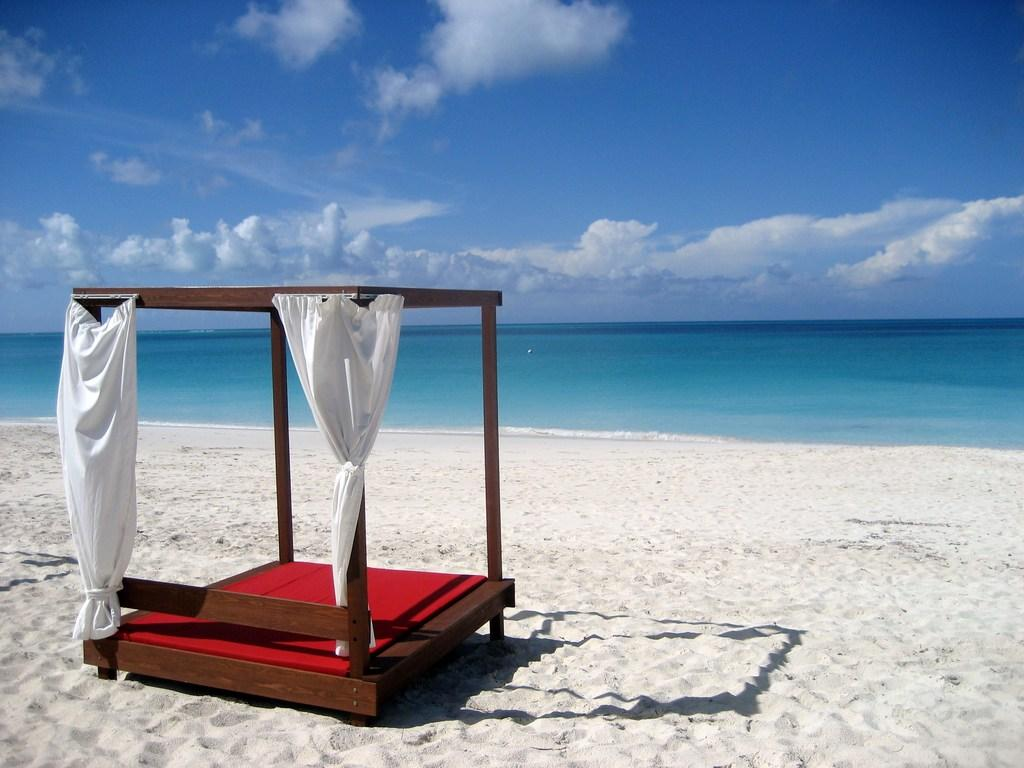What type of furniture is in the picture? There is a bed in the picture. What feature does the bed have? The bed has a curtain. What type of flooring is present in the picture? There is sand on the floor. What can be seen in the background of the picture? There is an ocean in the background of the picture. How is the sky depicted in the image? The sky is clear in the image. Where is the market located in the image? There is no market present in the image. What type of harmony is depicted in the image? The image does not depict any type of harmony. 